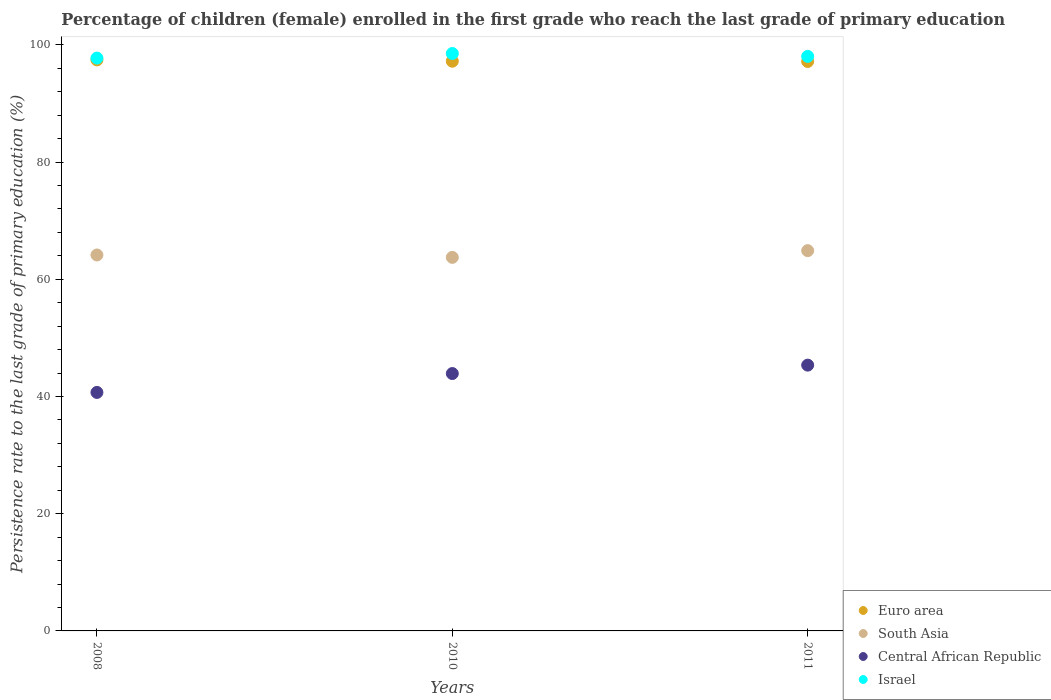What is the persistence rate of children in Israel in 2010?
Offer a very short reply. 98.53. Across all years, what is the maximum persistence rate of children in Euro area?
Offer a very short reply. 97.44. Across all years, what is the minimum persistence rate of children in Israel?
Give a very brief answer. 97.74. What is the total persistence rate of children in Central African Republic in the graph?
Provide a succinct answer. 129.97. What is the difference between the persistence rate of children in Central African Republic in 2008 and that in 2011?
Make the answer very short. -4.66. What is the difference between the persistence rate of children in South Asia in 2011 and the persistence rate of children in Central African Republic in 2010?
Your answer should be very brief. 20.97. What is the average persistence rate of children in South Asia per year?
Keep it short and to the point. 64.26. In the year 2011, what is the difference between the persistence rate of children in South Asia and persistence rate of children in Euro area?
Your answer should be compact. -32.28. In how many years, is the persistence rate of children in Euro area greater than 68 %?
Your response must be concise. 3. What is the ratio of the persistence rate of children in South Asia in 2008 to that in 2010?
Your answer should be compact. 1.01. What is the difference between the highest and the second highest persistence rate of children in Israel?
Make the answer very short. 0.49. What is the difference between the highest and the lowest persistence rate of children in Israel?
Offer a very short reply. 0.78. Is the sum of the persistence rate of children in South Asia in 2010 and 2011 greater than the maximum persistence rate of children in Central African Republic across all years?
Make the answer very short. Yes. Is it the case that in every year, the sum of the persistence rate of children in South Asia and persistence rate of children in Central African Republic  is greater than the sum of persistence rate of children in Israel and persistence rate of children in Euro area?
Your answer should be compact. No. Does the persistence rate of children in Euro area monotonically increase over the years?
Your answer should be compact. No. Is the persistence rate of children in Euro area strictly greater than the persistence rate of children in South Asia over the years?
Your answer should be very brief. Yes. What is the difference between two consecutive major ticks on the Y-axis?
Offer a very short reply. 20. Are the values on the major ticks of Y-axis written in scientific E-notation?
Provide a short and direct response. No. Does the graph contain any zero values?
Make the answer very short. No. Does the graph contain grids?
Your answer should be very brief. No. What is the title of the graph?
Your answer should be compact. Percentage of children (female) enrolled in the first grade who reach the last grade of primary education. Does "Bangladesh" appear as one of the legend labels in the graph?
Offer a very short reply. No. What is the label or title of the X-axis?
Offer a terse response. Years. What is the label or title of the Y-axis?
Give a very brief answer. Persistence rate to the last grade of primary education (%). What is the Persistence rate to the last grade of primary education (%) of Euro area in 2008?
Your answer should be compact. 97.44. What is the Persistence rate to the last grade of primary education (%) of South Asia in 2008?
Offer a very short reply. 64.15. What is the Persistence rate to the last grade of primary education (%) of Central African Republic in 2008?
Your answer should be very brief. 40.7. What is the Persistence rate to the last grade of primary education (%) in Israel in 2008?
Provide a short and direct response. 97.74. What is the Persistence rate to the last grade of primary education (%) of Euro area in 2010?
Provide a short and direct response. 97.21. What is the Persistence rate to the last grade of primary education (%) of South Asia in 2010?
Offer a terse response. 63.74. What is the Persistence rate to the last grade of primary education (%) of Central African Republic in 2010?
Offer a very short reply. 43.92. What is the Persistence rate to the last grade of primary education (%) of Israel in 2010?
Make the answer very short. 98.53. What is the Persistence rate to the last grade of primary education (%) of Euro area in 2011?
Ensure brevity in your answer.  97.17. What is the Persistence rate to the last grade of primary education (%) of South Asia in 2011?
Your response must be concise. 64.89. What is the Persistence rate to the last grade of primary education (%) of Central African Republic in 2011?
Keep it short and to the point. 45.35. What is the Persistence rate to the last grade of primary education (%) in Israel in 2011?
Provide a short and direct response. 98.04. Across all years, what is the maximum Persistence rate to the last grade of primary education (%) of Euro area?
Ensure brevity in your answer.  97.44. Across all years, what is the maximum Persistence rate to the last grade of primary education (%) in South Asia?
Your response must be concise. 64.89. Across all years, what is the maximum Persistence rate to the last grade of primary education (%) of Central African Republic?
Ensure brevity in your answer.  45.35. Across all years, what is the maximum Persistence rate to the last grade of primary education (%) of Israel?
Your answer should be very brief. 98.53. Across all years, what is the minimum Persistence rate to the last grade of primary education (%) in Euro area?
Ensure brevity in your answer.  97.17. Across all years, what is the minimum Persistence rate to the last grade of primary education (%) of South Asia?
Give a very brief answer. 63.74. Across all years, what is the minimum Persistence rate to the last grade of primary education (%) in Central African Republic?
Make the answer very short. 40.7. Across all years, what is the minimum Persistence rate to the last grade of primary education (%) of Israel?
Keep it short and to the point. 97.74. What is the total Persistence rate to the last grade of primary education (%) of Euro area in the graph?
Offer a very short reply. 291.82. What is the total Persistence rate to the last grade of primary education (%) of South Asia in the graph?
Provide a succinct answer. 192.78. What is the total Persistence rate to the last grade of primary education (%) in Central African Republic in the graph?
Your answer should be compact. 129.97. What is the total Persistence rate to the last grade of primary education (%) of Israel in the graph?
Provide a succinct answer. 294.31. What is the difference between the Persistence rate to the last grade of primary education (%) of Euro area in 2008 and that in 2010?
Your answer should be compact. 0.23. What is the difference between the Persistence rate to the last grade of primary education (%) in South Asia in 2008 and that in 2010?
Ensure brevity in your answer.  0.41. What is the difference between the Persistence rate to the last grade of primary education (%) in Central African Republic in 2008 and that in 2010?
Your answer should be compact. -3.22. What is the difference between the Persistence rate to the last grade of primary education (%) of Israel in 2008 and that in 2010?
Your answer should be very brief. -0.78. What is the difference between the Persistence rate to the last grade of primary education (%) in Euro area in 2008 and that in 2011?
Offer a terse response. 0.27. What is the difference between the Persistence rate to the last grade of primary education (%) of South Asia in 2008 and that in 2011?
Offer a terse response. -0.74. What is the difference between the Persistence rate to the last grade of primary education (%) in Central African Republic in 2008 and that in 2011?
Your answer should be very brief. -4.66. What is the difference between the Persistence rate to the last grade of primary education (%) in Israel in 2008 and that in 2011?
Provide a short and direct response. -0.29. What is the difference between the Persistence rate to the last grade of primary education (%) of Euro area in 2010 and that in 2011?
Your response must be concise. 0.05. What is the difference between the Persistence rate to the last grade of primary education (%) in South Asia in 2010 and that in 2011?
Offer a very short reply. -1.15. What is the difference between the Persistence rate to the last grade of primary education (%) in Central African Republic in 2010 and that in 2011?
Offer a terse response. -1.44. What is the difference between the Persistence rate to the last grade of primary education (%) of Israel in 2010 and that in 2011?
Offer a very short reply. 0.49. What is the difference between the Persistence rate to the last grade of primary education (%) of Euro area in 2008 and the Persistence rate to the last grade of primary education (%) of South Asia in 2010?
Your response must be concise. 33.7. What is the difference between the Persistence rate to the last grade of primary education (%) in Euro area in 2008 and the Persistence rate to the last grade of primary education (%) in Central African Republic in 2010?
Provide a succinct answer. 53.52. What is the difference between the Persistence rate to the last grade of primary education (%) of Euro area in 2008 and the Persistence rate to the last grade of primary education (%) of Israel in 2010?
Offer a very short reply. -1.09. What is the difference between the Persistence rate to the last grade of primary education (%) in South Asia in 2008 and the Persistence rate to the last grade of primary education (%) in Central African Republic in 2010?
Your answer should be compact. 20.23. What is the difference between the Persistence rate to the last grade of primary education (%) of South Asia in 2008 and the Persistence rate to the last grade of primary education (%) of Israel in 2010?
Offer a very short reply. -34.38. What is the difference between the Persistence rate to the last grade of primary education (%) of Central African Republic in 2008 and the Persistence rate to the last grade of primary education (%) of Israel in 2010?
Make the answer very short. -57.83. What is the difference between the Persistence rate to the last grade of primary education (%) of Euro area in 2008 and the Persistence rate to the last grade of primary education (%) of South Asia in 2011?
Provide a succinct answer. 32.55. What is the difference between the Persistence rate to the last grade of primary education (%) in Euro area in 2008 and the Persistence rate to the last grade of primary education (%) in Central African Republic in 2011?
Ensure brevity in your answer.  52.09. What is the difference between the Persistence rate to the last grade of primary education (%) of Euro area in 2008 and the Persistence rate to the last grade of primary education (%) of Israel in 2011?
Offer a very short reply. -0.6. What is the difference between the Persistence rate to the last grade of primary education (%) in South Asia in 2008 and the Persistence rate to the last grade of primary education (%) in Central African Republic in 2011?
Offer a very short reply. 18.8. What is the difference between the Persistence rate to the last grade of primary education (%) of South Asia in 2008 and the Persistence rate to the last grade of primary education (%) of Israel in 2011?
Give a very brief answer. -33.89. What is the difference between the Persistence rate to the last grade of primary education (%) of Central African Republic in 2008 and the Persistence rate to the last grade of primary education (%) of Israel in 2011?
Ensure brevity in your answer.  -57.34. What is the difference between the Persistence rate to the last grade of primary education (%) of Euro area in 2010 and the Persistence rate to the last grade of primary education (%) of South Asia in 2011?
Keep it short and to the point. 32.32. What is the difference between the Persistence rate to the last grade of primary education (%) in Euro area in 2010 and the Persistence rate to the last grade of primary education (%) in Central African Republic in 2011?
Your response must be concise. 51.86. What is the difference between the Persistence rate to the last grade of primary education (%) in Euro area in 2010 and the Persistence rate to the last grade of primary education (%) in Israel in 2011?
Ensure brevity in your answer.  -0.82. What is the difference between the Persistence rate to the last grade of primary education (%) in South Asia in 2010 and the Persistence rate to the last grade of primary education (%) in Central African Republic in 2011?
Your answer should be compact. 18.39. What is the difference between the Persistence rate to the last grade of primary education (%) of South Asia in 2010 and the Persistence rate to the last grade of primary education (%) of Israel in 2011?
Your response must be concise. -34.3. What is the difference between the Persistence rate to the last grade of primary education (%) in Central African Republic in 2010 and the Persistence rate to the last grade of primary education (%) in Israel in 2011?
Your response must be concise. -54.12. What is the average Persistence rate to the last grade of primary education (%) in Euro area per year?
Your answer should be compact. 97.27. What is the average Persistence rate to the last grade of primary education (%) in South Asia per year?
Provide a succinct answer. 64.26. What is the average Persistence rate to the last grade of primary education (%) of Central African Republic per year?
Provide a succinct answer. 43.32. What is the average Persistence rate to the last grade of primary education (%) of Israel per year?
Provide a short and direct response. 98.1. In the year 2008, what is the difference between the Persistence rate to the last grade of primary education (%) in Euro area and Persistence rate to the last grade of primary education (%) in South Asia?
Offer a very short reply. 33.29. In the year 2008, what is the difference between the Persistence rate to the last grade of primary education (%) of Euro area and Persistence rate to the last grade of primary education (%) of Central African Republic?
Your answer should be compact. 56.74. In the year 2008, what is the difference between the Persistence rate to the last grade of primary education (%) of Euro area and Persistence rate to the last grade of primary education (%) of Israel?
Ensure brevity in your answer.  -0.3. In the year 2008, what is the difference between the Persistence rate to the last grade of primary education (%) in South Asia and Persistence rate to the last grade of primary education (%) in Central African Republic?
Keep it short and to the point. 23.45. In the year 2008, what is the difference between the Persistence rate to the last grade of primary education (%) of South Asia and Persistence rate to the last grade of primary education (%) of Israel?
Keep it short and to the point. -33.6. In the year 2008, what is the difference between the Persistence rate to the last grade of primary education (%) in Central African Republic and Persistence rate to the last grade of primary education (%) in Israel?
Your answer should be compact. -57.05. In the year 2010, what is the difference between the Persistence rate to the last grade of primary education (%) in Euro area and Persistence rate to the last grade of primary education (%) in South Asia?
Make the answer very short. 33.47. In the year 2010, what is the difference between the Persistence rate to the last grade of primary education (%) of Euro area and Persistence rate to the last grade of primary education (%) of Central African Republic?
Provide a short and direct response. 53.3. In the year 2010, what is the difference between the Persistence rate to the last grade of primary education (%) of Euro area and Persistence rate to the last grade of primary education (%) of Israel?
Your answer should be very brief. -1.31. In the year 2010, what is the difference between the Persistence rate to the last grade of primary education (%) in South Asia and Persistence rate to the last grade of primary education (%) in Central African Republic?
Your answer should be very brief. 19.82. In the year 2010, what is the difference between the Persistence rate to the last grade of primary education (%) of South Asia and Persistence rate to the last grade of primary education (%) of Israel?
Your response must be concise. -34.78. In the year 2010, what is the difference between the Persistence rate to the last grade of primary education (%) in Central African Republic and Persistence rate to the last grade of primary education (%) in Israel?
Ensure brevity in your answer.  -54.61. In the year 2011, what is the difference between the Persistence rate to the last grade of primary education (%) of Euro area and Persistence rate to the last grade of primary education (%) of South Asia?
Make the answer very short. 32.28. In the year 2011, what is the difference between the Persistence rate to the last grade of primary education (%) of Euro area and Persistence rate to the last grade of primary education (%) of Central African Republic?
Ensure brevity in your answer.  51.81. In the year 2011, what is the difference between the Persistence rate to the last grade of primary education (%) of Euro area and Persistence rate to the last grade of primary education (%) of Israel?
Make the answer very short. -0.87. In the year 2011, what is the difference between the Persistence rate to the last grade of primary education (%) in South Asia and Persistence rate to the last grade of primary education (%) in Central African Republic?
Ensure brevity in your answer.  19.54. In the year 2011, what is the difference between the Persistence rate to the last grade of primary education (%) of South Asia and Persistence rate to the last grade of primary education (%) of Israel?
Offer a very short reply. -33.15. In the year 2011, what is the difference between the Persistence rate to the last grade of primary education (%) in Central African Republic and Persistence rate to the last grade of primary education (%) in Israel?
Provide a short and direct response. -52.68. What is the ratio of the Persistence rate to the last grade of primary education (%) of South Asia in 2008 to that in 2010?
Offer a terse response. 1.01. What is the ratio of the Persistence rate to the last grade of primary education (%) of Central African Republic in 2008 to that in 2010?
Give a very brief answer. 0.93. What is the ratio of the Persistence rate to the last grade of primary education (%) in Central African Republic in 2008 to that in 2011?
Keep it short and to the point. 0.9. What is the ratio of the Persistence rate to the last grade of primary education (%) of South Asia in 2010 to that in 2011?
Your answer should be very brief. 0.98. What is the ratio of the Persistence rate to the last grade of primary education (%) of Central African Republic in 2010 to that in 2011?
Ensure brevity in your answer.  0.97. What is the difference between the highest and the second highest Persistence rate to the last grade of primary education (%) in Euro area?
Give a very brief answer. 0.23. What is the difference between the highest and the second highest Persistence rate to the last grade of primary education (%) in South Asia?
Provide a succinct answer. 0.74. What is the difference between the highest and the second highest Persistence rate to the last grade of primary education (%) in Central African Republic?
Offer a very short reply. 1.44. What is the difference between the highest and the second highest Persistence rate to the last grade of primary education (%) in Israel?
Keep it short and to the point. 0.49. What is the difference between the highest and the lowest Persistence rate to the last grade of primary education (%) in Euro area?
Make the answer very short. 0.27. What is the difference between the highest and the lowest Persistence rate to the last grade of primary education (%) in South Asia?
Your response must be concise. 1.15. What is the difference between the highest and the lowest Persistence rate to the last grade of primary education (%) of Central African Republic?
Provide a succinct answer. 4.66. What is the difference between the highest and the lowest Persistence rate to the last grade of primary education (%) in Israel?
Offer a terse response. 0.78. 